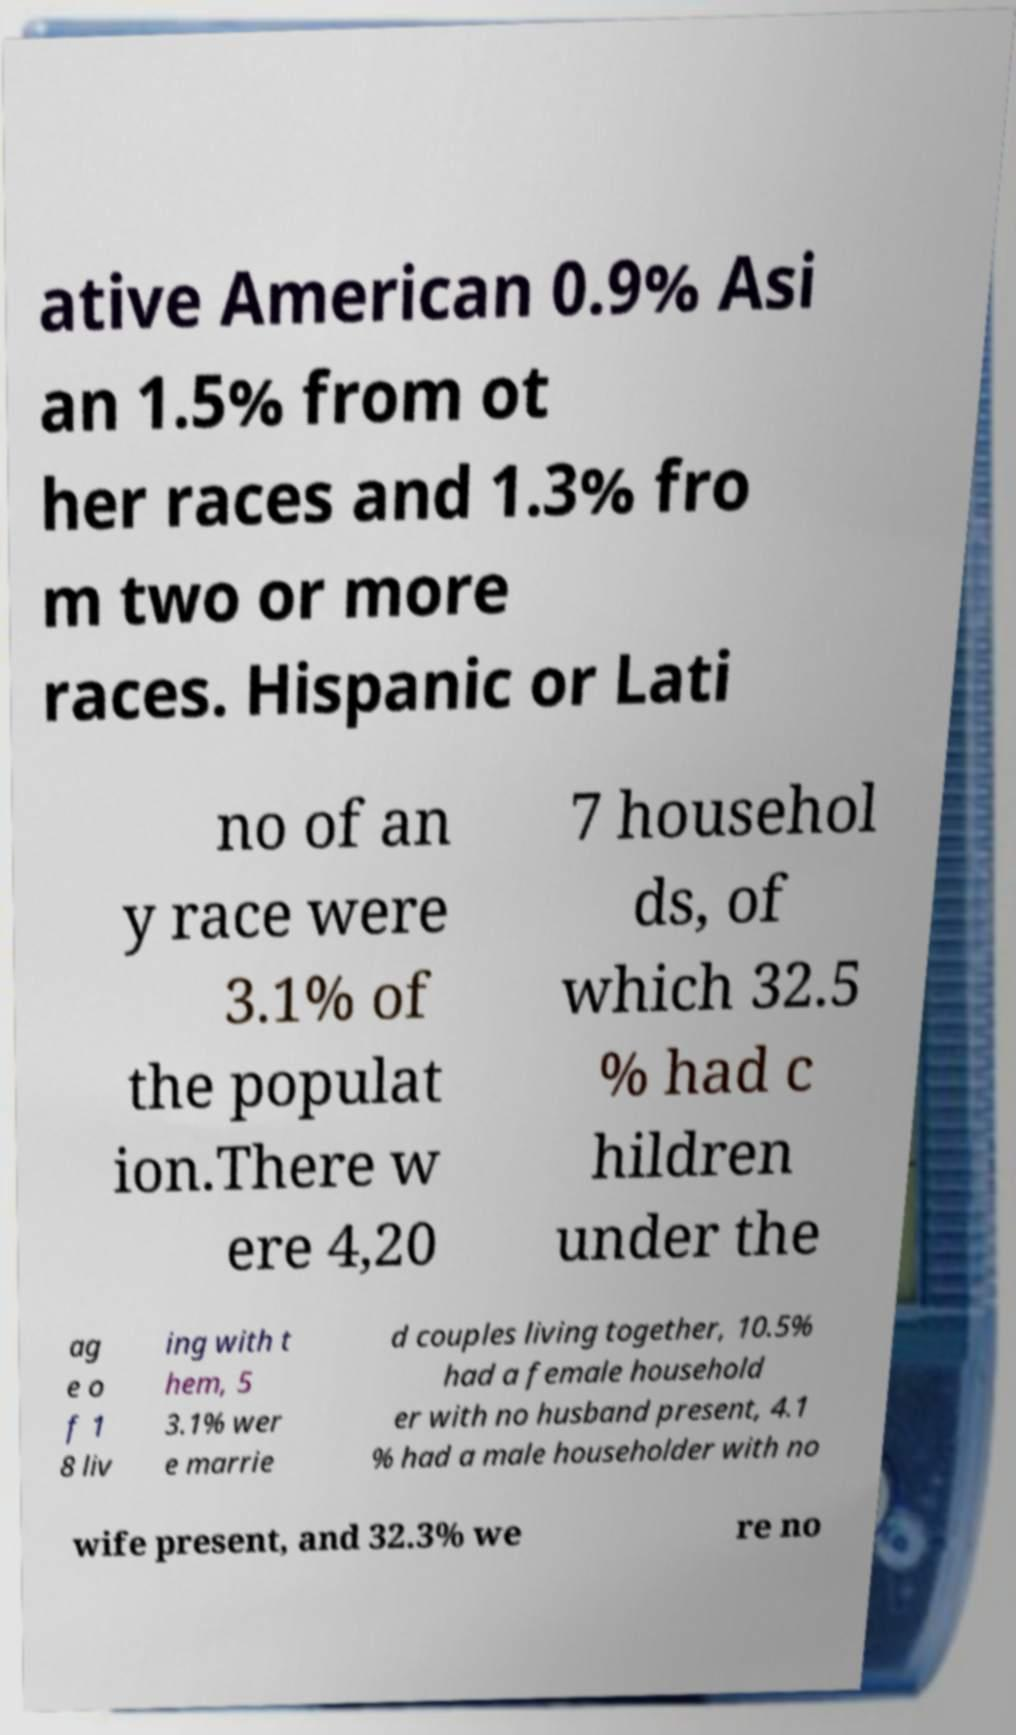For documentation purposes, I need the text within this image transcribed. Could you provide that? ative American 0.9% Asi an 1.5% from ot her races and 1.3% fro m two or more races. Hispanic or Lati no of an y race were 3.1% of the populat ion.There w ere 4,20 7 househol ds, of which 32.5 % had c hildren under the ag e o f 1 8 liv ing with t hem, 5 3.1% wer e marrie d couples living together, 10.5% had a female household er with no husband present, 4.1 % had a male householder with no wife present, and 32.3% we re no 